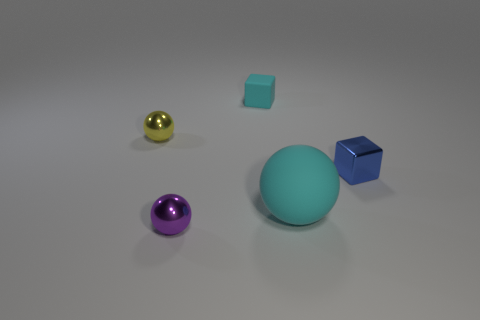Add 1 purple cubes. How many objects exist? 6 Subtract all balls. How many objects are left? 2 Subtract 1 cyan balls. How many objects are left? 4 Subtract all big brown matte things. Subtract all blue shiny things. How many objects are left? 4 Add 4 cyan things. How many cyan things are left? 6 Add 3 shiny balls. How many shiny balls exist? 5 